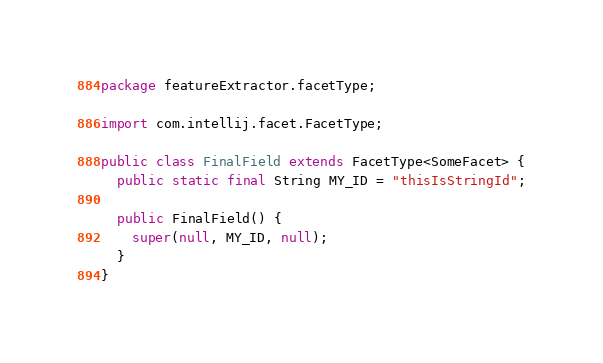Convert code to text. <code><loc_0><loc_0><loc_500><loc_500><_Java_>package featureExtractor.facetType;

import com.intellij.facet.FacetType;

public class FinalField extends FacetType<SomeFacet> {
  public static final String MY_ID = "thisIsStringId";

  public FinalField() {
    super(null, MY_ID, null);
  }
}
</code> 